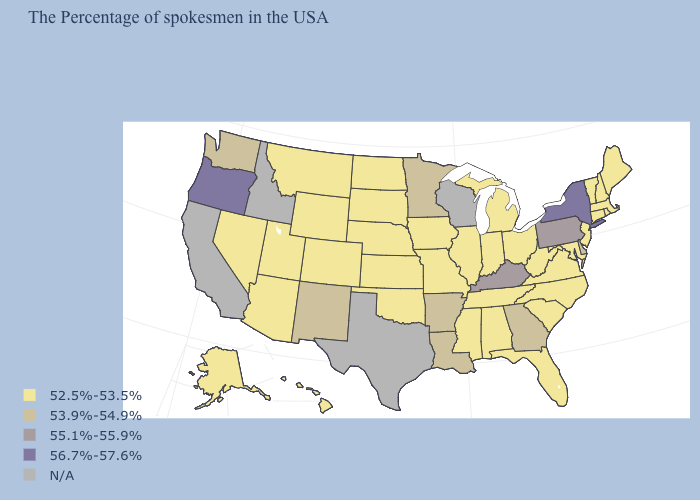What is the lowest value in the South?
Answer briefly. 52.5%-53.5%. What is the value of Virginia?
Short answer required. 52.5%-53.5%. What is the value of Iowa?
Answer briefly. 52.5%-53.5%. Name the states that have a value in the range 52.5%-53.5%?
Be succinct. Maine, Massachusetts, Rhode Island, New Hampshire, Vermont, Connecticut, New Jersey, Maryland, Virginia, North Carolina, South Carolina, West Virginia, Ohio, Florida, Michigan, Indiana, Alabama, Tennessee, Illinois, Mississippi, Missouri, Iowa, Kansas, Nebraska, Oklahoma, South Dakota, North Dakota, Wyoming, Colorado, Utah, Montana, Arizona, Nevada, Alaska, Hawaii. How many symbols are there in the legend?
Keep it brief. 5. Does the first symbol in the legend represent the smallest category?
Concise answer only. Yes. What is the value of Florida?
Give a very brief answer. 52.5%-53.5%. What is the value of Connecticut?
Short answer required. 52.5%-53.5%. Name the states that have a value in the range 55.1%-55.9%?
Quick response, please. Pennsylvania, Kentucky. Does South Dakota have the lowest value in the USA?
Be succinct. Yes. What is the value of New York?
Write a very short answer. 56.7%-57.6%. Name the states that have a value in the range 56.7%-57.6%?
Short answer required. New York, Oregon. What is the value of New Jersey?
Short answer required. 52.5%-53.5%. What is the highest value in states that border Oregon?
Short answer required. 53.9%-54.9%. 